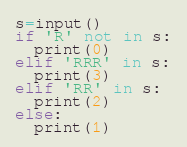Convert code to text. <code><loc_0><loc_0><loc_500><loc_500><_Python_>s=input()
if 'R' not in s:
  print(0)
elif 'RRR' in s:
  print(3)
elif 'RR' in s:
  print(2)
else:
  print(1)</code> 